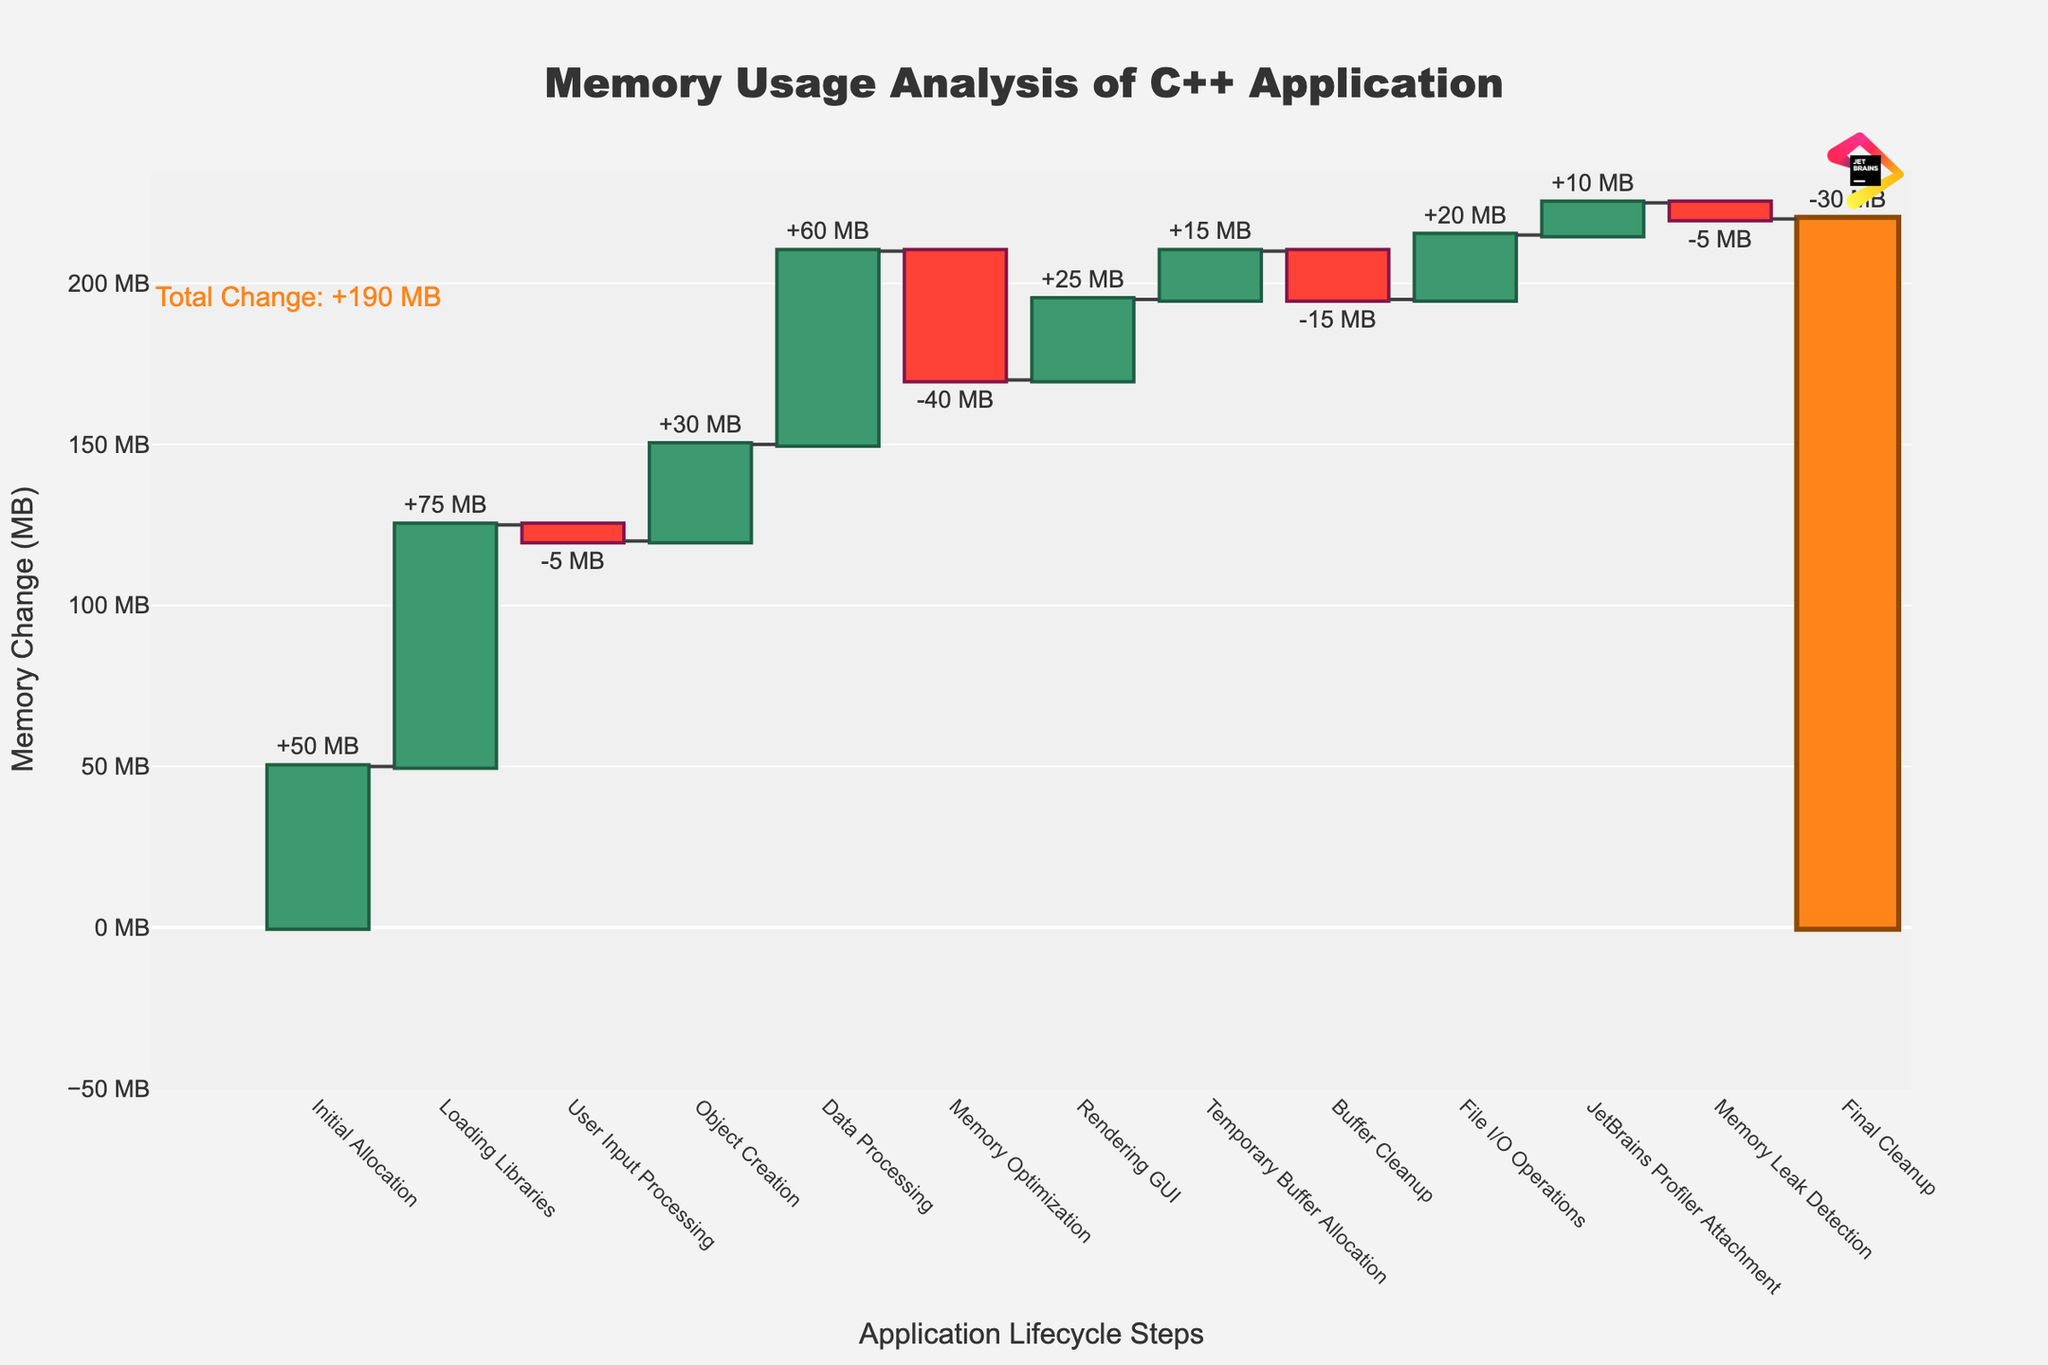what is the title of the waterfall chart? The title of the waterfall chart is displayed at the top center of the figure. It provides an overview of what the chart is depicting.
Answer: Memory Usage Analysis of C++ Application what is the initial memory allocation? The initial memory allocation is shown as the first bar on the waterfall chart. It indicates the starting memory usage of the application.
Answer: 50 MB what is the total memory change by the end of the lifecycle? To find the total memory change, we look at the annotation in the chart indicating the total change.
Answer: +140 MB what is the largest increase in memory usage? The largest increase in memory usage can be determined by finding the tallest green bar which denotes the highest positive memory change.
Answer: Loading Libraries, 75 MB what step has the highest decrease in memory usage? The highest decrease in memory usage is shown by the tallest red bar, which indicates the largest negative memory change.
Answer: Memory Optimization, -40 MB what steps contribute to reaching the peak memory usage? To determine the steps that lead to the peak memory usage, observe the bars leading up to the highest black line on the chart. The steps to consider are those before "Memory Optimization".
Answer: Initial Allocation, Loading Libraries, Object Creation, Data Processing what is the memory usage after loading libraries? The memory usage after loading libraries is shown as the running total at the end of the "Loading Libraries" step.
Answer: 125 MB compare the memory usage difference between user input processing and rendering GUI The "User Input Processing" step shows -5 MB change, while "Rendering GUI" step shows +25 MB change. To compare, subtract the first from the second: 25 MB - (-5 MB).
Answer: 30 MB what is the difference in running total memory from object creation to final cleanup? The running total memory after "Object Creation" is 150 MB and for "Final Cleanup" it's 190 MB. To find the difference, subtract the first from the second.
Answer: 40 MB how does the attachment of JetBrains profiler affect memory? The "JetBrains Profiler Attachment" step has a positive memory change, which is indicated by a green bar. The specific amount can be read from the bar.
Answer: +10 MB 